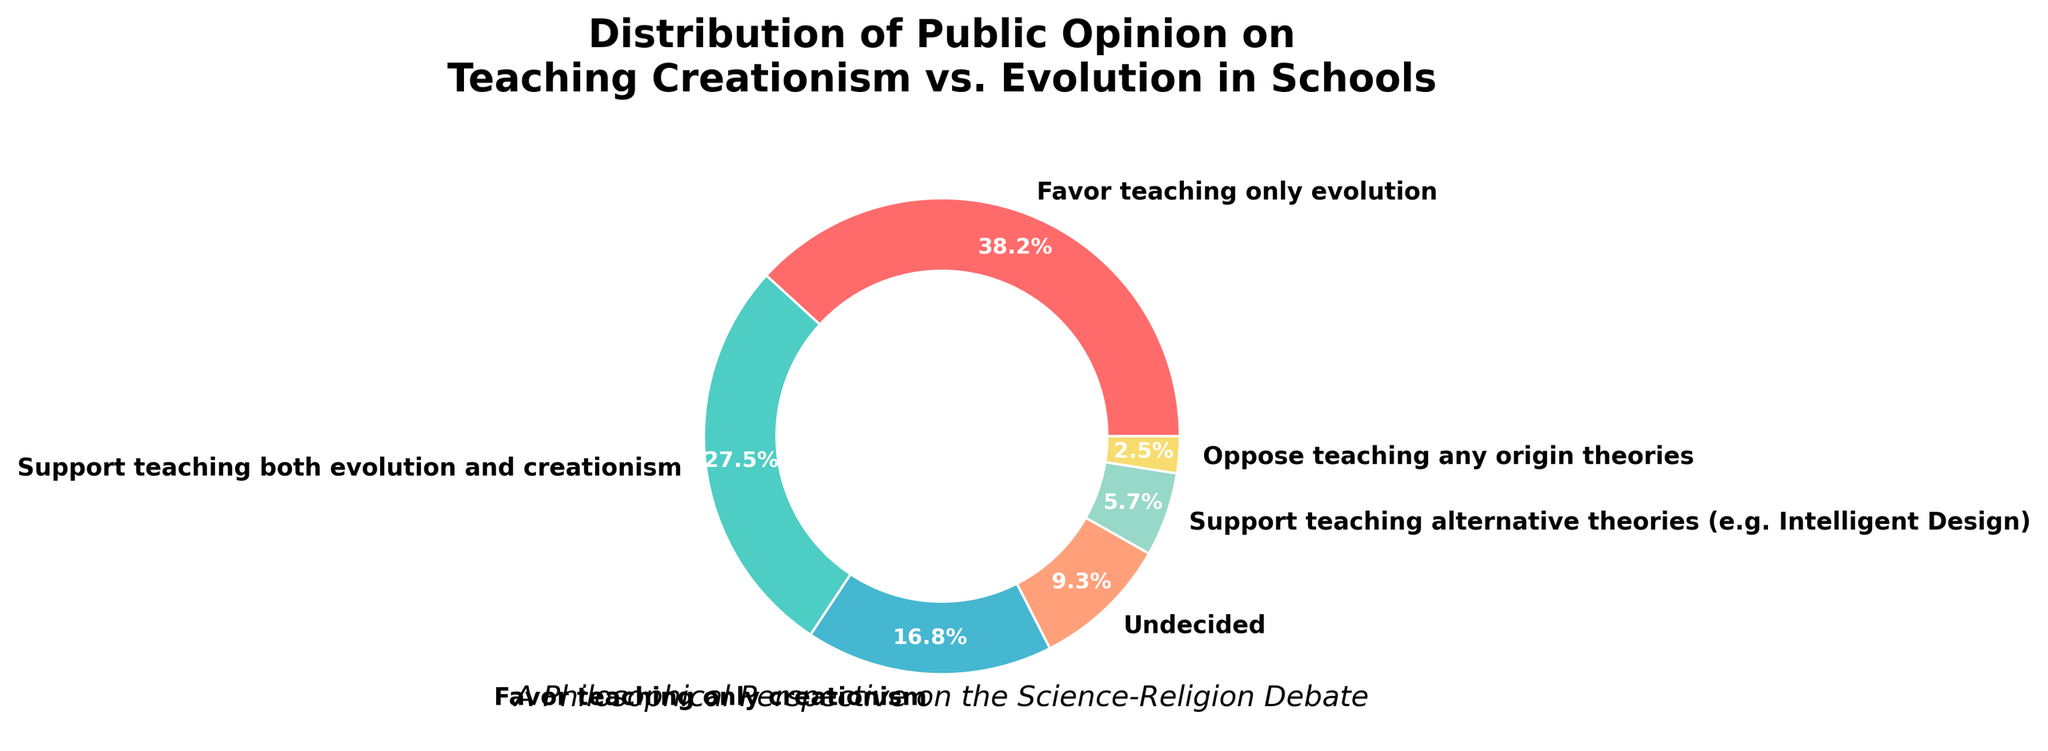What's the total percentage of people who favor teaching only one theory, either creationism or evolution? Adding the percentages of people who favor teaching only evolution (38.2%) and those who favor teaching only creationism (16.8%) gives 38.2% + 16.8% = 55%.
Answer: 55% Which group is larger: those who are undecided or those who oppose teaching any origin theories? Comparing the two percentages, the undecided group is 9.3%, while the group opposing any origin theories is 2.5%. Since 9.3% is greater than 2.5%, the undecided group is larger.
Answer: Undecided group What percentage of people support teaching multiple perspectives (e.g., both evolution and creationism, alternative theories)? Adding the percentages of people who support teaching both evolution and creationism (27.5%) and those who support teaching alternative theories like Intelligent Design (5.7%) gives 27.5% + 5.7% = 33.2%.
Answer: 33.2% How much greater is the percentage of people who favor teaching only evolution compared to those who favor teaching only creationism? Subtracting the percentage of those who favor teaching only creationism (16.8%) from those who favor teaching only evolution (38.2%) gives 38.2% - 16.8% = 21.4%.
Answer: 21.4% Which segment of the pie chart is represented by the red color? From the visual characteristics provided, the segment represented by red corresponds to the category "Favor teaching only evolution".
Answer: Favor teaching only evolution Is the sum of the percentages of people who support teaching only creationism and those who are undecided higher than the percentage of people who support teaching both evolution and creationism? Adding the percentages of people who favor teaching only creationism (16.8%) and those who are undecided (9.3%) gives 16.8% + 9.3% = 26.1%. Since 26.1% is less than 27.5%, the sum is not higher.
Answer: No What percentage is represented by the smallest segment in the pie chart? The smallest segment, representing those who oppose teaching any origin theories, is 2.5%.
Answer: 2.5% What is the difference between the highest and the lowest percentage values? Subtracting the smallest percentage (2.5% for those who oppose teaching any origin theories) from the largest percentage (38.2% for those who favor teaching only evolution) gives 38.2% - 2.5% = 35.7%.
Answer: 35.7% What fraction of people support teaching either both theories together or only one theory? Adding the percentages for those supporting both theories (27.5%) and those in favor of teaching only one theory (38.2% for evolution and 16.8% for creationism) gives 27.5% + 38.2% + 16.8% = 82.5%.
Answer: 82.5% 